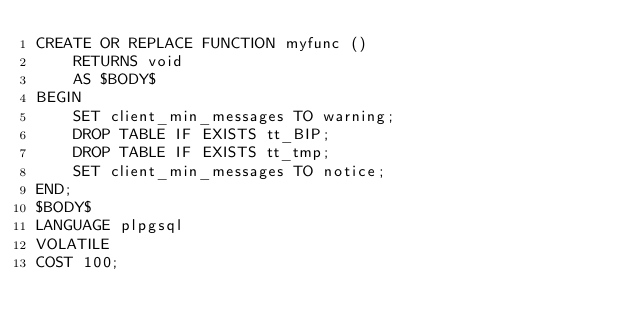Convert code to text. <code><loc_0><loc_0><loc_500><loc_500><_SQL_>CREATE OR REPLACE FUNCTION myfunc ()
    RETURNS void
    AS $BODY$
BEGIN
    SET client_min_messages TO warning;
    DROP TABLE IF EXISTS tt_BIP;
    DROP TABLE IF EXISTS tt_tmp;
    SET client_min_messages TO notice;
END;
$BODY$
LANGUAGE plpgsql
VOLATILE
COST 100;

</code> 